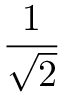Convert formula to latex. <formula><loc_0><loc_0><loc_500><loc_500>\frac { 1 } { \sqrt { 2 } }</formula> 